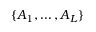<formula> <loc_0><loc_0><loc_500><loc_500>\{ A _ { 1 } , \dots , A _ { L } \}</formula> 